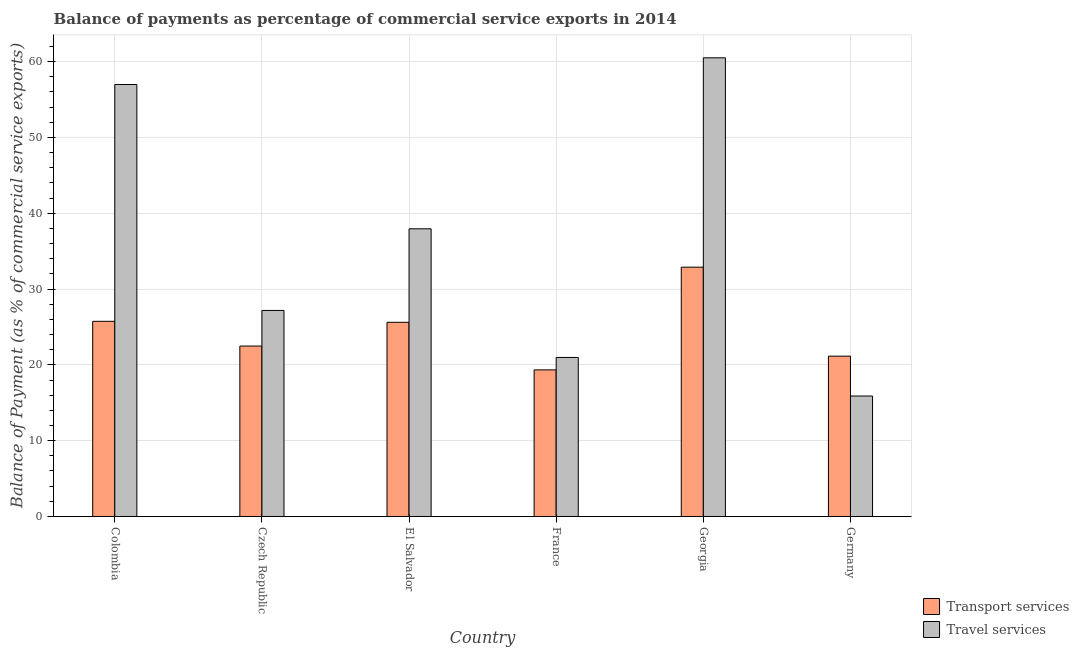How many groups of bars are there?
Keep it short and to the point. 6. Are the number of bars per tick equal to the number of legend labels?
Offer a terse response. Yes. Are the number of bars on each tick of the X-axis equal?
Your answer should be very brief. Yes. What is the label of the 3rd group of bars from the left?
Make the answer very short. El Salvador. In how many cases, is the number of bars for a given country not equal to the number of legend labels?
Your response must be concise. 0. What is the balance of payments of travel services in Colombia?
Ensure brevity in your answer.  56.98. Across all countries, what is the maximum balance of payments of transport services?
Ensure brevity in your answer.  32.89. Across all countries, what is the minimum balance of payments of travel services?
Your response must be concise. 15.89. In which country was the balance of payments of transport services maximum?
Keep it short and to the point. Georgia. In which country was the balance of payments of travel services minimum?
Your answer should be compact. Germany. What is the total balance of payments of transport services in the graph?
Provide a succinct answer. 147.21. What is the difference between the balance of payments of transport services in Georgia and that in Germany?
Keep it short and to the point. 11.74. What is the difference between the balance of payments of transport services in Germany and the balance of payments of travel services in France?
Your response must be concise. 0.17. What is the average balance of payments of travel services per country?
Your answer should be compact. 36.58. What is the difference between the balance of payments of transport services and balance of payments of travel services in Georgia?
Ensure brevity in your answer.  -27.61. In how many countries, is the balance of payments of travel services greater than 18 %?
Provide a short and direct response. 5. What is the ratio of the balance of payments of travel services in Czech Republic to that in France?
Keep it short and to the point. 1.3. Is the balance of payments of transport services in Colombia less than that in Georgia?
Offer a terse response. Yes. What is the difference between the highest and the second highest balance of payments of travel services?
Provide a succinct answer. 3.52. What is the difference between the highest and the lowest balance of payments of travel services?
Give a very brief answer. 44.61. What does the 1st bar from the left in Czech Republic represents?
Ensure brevity in your answer.  Transport services. What does the 1st bar from the right in Czech Republic represents?
Offer a terse response. Travel services. How many bars are there?
Make the answer very short. 12. Are all the bars in the graph horizontal?
Offer a terse response. No. How many countries are there in the graph?
Offer a very short reply. 6. What is the difference between two consecutive major ticks on the Y-axis?
Your answer should be compact. 10. Are the values on the major ticks of Y-axis written in scientific E-notation?
Provide a succinct answer. No. Does the graph contain any zero values?
Offer a terse response. No. Does the graph contain grids?
Ensure brevity in your answer.  Yes. Where does the legend appear in the graph?
Make the answer very short. Bottom right. How are the legend labels stacked?
Your answer should be very brief. Vertical. What is the title of the graph?
Offer a very short reply. Balance of payments as percentage of commercial service exports in 2014. Does "Current education expenditure" appear as one of the legend labels in the graph?
Your answer should be very brief. No. What is the label or title of the Y-axis?
Your response must be concise. Balance of Payment (as % of commercial service exports). What is the Balance of Payment (as % of commercial service exports) of Transport services in Colombia?
Your answer should be very brief. 25.74. What is the Balance of Payment (as % of commercial service exports) of Travel services in Colombia?
Offer a terse response. 56.98. What is the Balance of Payment (as % of commercial service exports) of Transport services in Czech Republic?
Ensure brevity in your answer.  22.48. What is the Balance of Payment (as % of commercial service exports) in Travel services in Czech Republic?
Give a very brief answer. 27.18. What is the Balance of Payment (as % of commercial service exports) of Transport services in El Salvador?
Make the answer very short. 25.61. What is the Balance of Payment (as % of commercial service exports) of Travel services in El Salvador?
Provide a short and direct response. 37.95. What is the Balance of Payment (as % of commercial service exports) in Transport services in France?
Keep it short and to the point. 19.34. What is the Balance of Payment (as % of commercial service exports) in Travel services in France?
Provide a succinct answer. 20.98. What is the Balance of Payment (as % of commercial service exports) in Transport services in Georgia?
Provide a short and direct response. 32.89. What is the Balance of Payment (as % of commercial service exports) of Travel services in Georgia?
Provide a short and direct response. 60.5. What is the Balance of Payment (as % of commercial service exports) of Transport services in Germany?
Your response must be concise. 21.15. What is the Balance of Payment (as % of commercial service exports) in Travel services in Germany?
Keep it short and to the point. 15.89. Across all countries, what is the maximum Balance of Payment (as % of commercial service exports) of Transport services?
Offer a very short reply. 32.89. Across all countries, what is the maximum Balance of Payment (as % of commercial service exports) in Travel services?
Provide a succinct answer. 60.5. Across all countries, what is the minimum Balance of Payment (as % of commercial service exports) in Transport services?
Make the answer very short. 19.34. Across all countries, what is the minimum Balance of Payment (as % of commercial service exports) in Travel services?
Your answer should be very brief. 15.89. What is the total Balance of Payment (as % of commercial service exports) in Transport services in the graph?
Your response must be concise. 147.21. What is the total Balance of Payment (as % of commercial service exports) in Travel services in the graph?
Your response must be concise. 219.47. What is the difference between the Balance of Payment (as % of commercial service exports) of Transport services in Colombia and that in Czech Republic?
Offer a terse response. 3.26. What is the difference between the Balance of Payment (as % of commercial service exports) in Travel services in Colombia and that in Czech Republic?
Your answer should be compact. 29.8. What is the difference between the Balance of Payment (as % of commercial service exports) in Transport services in Colombia and that in El Salvador?
Ensure brevity in your answer.  0.13. What is the difference between the Balance of Payment (as % of commercial service exports) in Travel services in Colombia and that in El Salvador?
Offer a terse response. 19.03. What is the difference between the Balance of Payment (as % of commercial service exports) in Transport services in Colombia and that in France?
Give a very brief answer. 6.41. What is the difference between the Balance of Payment (as % of commercial service exports) of Travel services in Colombia and that in France?
Offer a terse response. 36.01. What is the difference between the Balance of Payment (as % of commercial service exports) in Transport services in Colombia and that in Georgia?
Offer a terse response. -7.14. What is the difference between the Balance of Payment (as % of commercial service exports) of Travel services in Colombia and that in Georgia?
Your response must be concise. -3.52. What is the difference between the Balance of Payment (as % of commercial service exports) in Transport services in Colombia and that in Germany?
Your response must be concise. 4.6. What is the difference between the Balance of Payment (as % of commercial service exports) of Travel services in Colombia and that in Germany?
Make the answer very short. 41.09. What is the difference between the Balance of Payment (as % of commercial service exports) of Transport services in Czech Republic and that in El Salvador?
Make the answer very short. -3.13. What is the difference between the Balance of Payment (as % of commercial service exports) in Travel services in Czech Republic and that in El Salvador?
Make the answer very short. -10.77. What is the difference between the Balance of Payment (as % of commercial service exports) of Transport services in Czech Republic and that in France?
Your answer should be compact. 3.14. What is the difference between the Balance of Payment (as % of commercial service exports) in Travel services in Czech Republic and that in France?
Provide a short and direct response. 6.2. What is the difference between the Balance of Payment (as % of commercial service exports) of Transport services in Czech Republic and that in Georgia?
Make the answer very short. -10.41. What is the difference between the Balance of Payment (as % of commercial service exports) in Travel services in Czech Republic and that in Georgia?
Your answer should be compact. -33.32. What is the difference between the Balance of Payment (as % of commercial service exports) in Transport services in Czech Republic and that in Germany?
Offer a terse response. 1.33. What is the difference between the Balance of Payment (as % of commercial service exports) in Travel services in Czech Republic and that in Germany?
Provide a succinct answer. 11.29. What is the difference between the Balance of Payment (as % of commercial service exports) in Transport services in El Salvador and that in France?
Give a very brief answer. 6.28. What is the difference between the Balance of Payment (as % of commercial service exports) in Travel services in El Salvador and that in France?
Provide a short and direct response. 16.97. What is the difference between the Balance of Payment (as % of commercial service exports) of Transport services in El Salvador and that in Georgia?
Your answer should be compact. -7.27. What is the difference between the Balance of Payment (as % of commercial service exports) of Travel services in El Salvador and that in Georgia?
Provide a succinct answer. -22.56. What is the difference between the Balance of Payment (as % of commercial service exports) of Transport services in El Salvador and that in Germany?
Your answer should be compact. 4.47. What is the difference between the Balance of Payment (as % of commercial service exports) in Travel services in El Salvador and that in Germany?
Offer a terse response. 22.06. What is the difference between the Balance of Payment (as % of commercial service exports) of Transport services in France and that in Georgia?
Offer a very short reply. -13.55. What is the difference between the Balance of Payment (as % of commercial service exports) in Travel services in France and that in Georgia?
Your answer should be very brief. -39.53. What is the difference between the Balance of Payment (as % of commercial service exports) in Transport services in France and that in Germany?
Offer a very short reply. -1.81. What is the difference between the Balance of Payment (as % of commercial service exports) in Travel services in France and that in Germany?
Provide a succinct answer. 5.09. What is the difference between the Balance of Payment (as % of commercial service exports) of Transport services in Georgia and that in Germany?
Provide a short and direct response. 11.74. What is the difference between the Balance of Payment (as % of commercial service exports) of Travel services in Georgia and that in Germany?
Your response must be concise. 44.61. What is the difference between the Balance of Payment (as % of commercial service exports) of Transport services in Colombia and the Balance of Payment (as % of commercial service exports) of Travel services in Czech Republic?
Keep it short and to the point. -1.43. What is the difference between the Balance of Payment (as % of commercial service exports) of Transport services in Colombia and the Balance of Payment (as % of commercial service exports) of Travel services in El Salvador?
Offer a very short reply. -12.2. What is the difference between the Balance of Payment (as % of commercial service exports) in Transport services in Colombia and the Balance of Payment (as % of commercial service exports) in Travel services in France?
Ensure brevity in your answer.  4.77. What is the difference between the Balance of Payment (as % of commercial service exports) in Transport services in Colombia and the Balance of Payment (as % of commercial service exports) in Travel services in Georgia?
Keep it short and to the point. -34.76. What is the difference between the Balance of Payment (as % of commercial service exports) of Transport services in Colombia and the Balance of Payment (as % of commercial service exports) of Travel services in Germany?
Your response must be concise. 9.85. What is the difference between the Balance of Payment (as % of commercial service exports) in Transport services in Czech Republic and the Balance of Payment (as % of commercial service exports) in Travel services in El Salvador?
Keep it short and to the point. -15.47. What is the difference between the Balance of Payment (as % of commercial service exports) in Transport services in Czech Republic and the Balance of Payment (as % of commercial service exports) in Travel services in France?
Ensure brevity in your answer.  1.5. What is the difference between the Balance of Payment (as % of commercial service exports) in Transport services in Czech Republic and the Balance of Payment (as % of commercial service exports) in Travel services in Georgia?
Provide a short and direct response. -38.02. What is the difference between the Balance of Payment (as % of commercial service exports) in Transport services in Czech Republic and the Balance of Payment (as % of commercial service exports) in Travel services in Germany?
Your answer should be very brief. 6.59. What is the difference between the Balance of Payment (as % of commercial service exports) of Transport services in El Salvador and the Balance of Payment (as % of commercial service exports) of Travel services in France?
Your response must be concise. 4.64. What is the difference between the Balance of Payment (as % of commercial service exports) in Transport services in El Salvador and the Balance of Payment (as % of commercial service exports) in Travel services in Georgia?
Keep it short and to the point. -34.89. What is the difference between the Balance of Payment (as % of commercial service exports) in Transport services in El Salvador and the Balance of Payment (as % of commercial service exports) in Travel services in Germany?
Provide a short and direct response. 9.73. What is the difference between the Balance of Payment (as % of commercial service exports) in Transport services in France and the Balance of Payment (as % of commercial service exports) in Travel services in Georgia?
Your answer should be compact. -41.17. What is the difference between the Balance of Payment (as % of commercial service exports) in Transport services in France and the Balance of Payment (as % of commercial service exports) in Travel services in Germany?
Provide a short and direct response. 3.45. What is the difference between the Balance of Payment (as % of commercial service exports) of Transport services in Georgia and the Balance of Payment (as % of commercial service exports) of Travel services in Germany?
Keep it short and to the point. 17. What is the average Balance of Payment (as % of commercial service exports) of Transport services per country?
Provide a short and direct response. 24.54. What is the average Balance of Payment (as % of commercial service exports) in Travel services per country?
Your response must be concise. 36.58. What is the difference between the Balance of Payment (as % of commercial service exports) in Transport services and Balance of Payment (as % of commercial service exports) in Travel services in Colombia?
Your answer should be very brief. -31.24. What is the difference between the Balance of Payment (as % of commercial service exports) in Transport services and Balance of Payment (as % of commercial service exports) in Travel services in Czech Republic?
Make the answer very short. -4.7. What is the difference between the Balance of Payment (as % of commercial service exports) of Transport services and Balance of Payment (as % of commercial service exports) of Travel services in El Salvador?
Provide a succinct answer. -12.33. What is the difference between the Balance of Payment (as % of commercial service exports) in Transport services and Balance of Payment (as % of commercial service exports) in Travel services in France?
Keep it short and to the point. -1.64. What is the difference between the Balance of Payment (as % of commercial service exports) of Transport services and Balance of Payment (as % of commercial service exports) of Travel services in Georgia?
Ensure brevity in your answer.  -27.61. What is the difference between the Balance of Payment (as % of commercial service exports) in Transport services and Balance of Payment (as % of commercial service exports) in Travel services in Germany?
Make the answer very short. 5.26. What is the ratio of the Balance of Payment (as % of commercial service exports) of Transport services in Colombia to that in Czech Republic?
Give a very brief answer. 1.15. What is the ratio of the Balance of Payment (as % of commercial service exports) in Travel services in Colombia to that in Czech Republic?
Provide a succinct answer. 2.1. What is the ratio of the Balance of Payment (as % of commercial service exports) of Transport services in Colombia to that in El Salvador?
Provide a short and direct response. 1.01. What is the ratio of the Balance of Payment (as % of commercial service exports) of Travel services in Colombia to that in El Salvador?
Your answer should be compact. 1.5. What is the ratio of the Balance of Payment (as % of commercial service exports) of Transport services in Colombia to that in France?
Keep it short and to the point. 1.33. What is the ratio of the Balance of Payment (as % of commercial service exports) in Travel services in Colombia to that in France?
Make the answer very short. 2.72. What is the ratio of the Balance of Payment (as % of commercial service exports) of Transport services in Colombia to that in Georgia?
Make the answer very short. 0.78. What is the ratio of the Balance of Payment (as % of commercial service exports) in Travel services in Colombia to that in Georgia?
Your answer should be compact. 0.94. What is the ratio of the Balance of Payment (as % of commercial service exports) of Transport services in Colombia to that in Germany?
Keep it short and to the point. 1.22. What is the ratio of the Balance of Payment (as % of commercial service exports) of Travel services in Colombia to that in Germany?
Offer a very short reply. 3.59. What is the ratio of the Balance of Payment (as % of commercial service exports) of Transport services in Czech Republic to that in El Salvador?
Your response must be concise. 0.88. What is the ratio of the Balance of Payment (as % of commercial service exports) of Travel services in Czech Republic to that in El Salvador?
Your response must be concise. 0.72. What is the ratio of the Balance of Payment (as % of commercial service exports) of Transport services in Czech Republic to that in France?
Give a very brief answer. 1.16. What is the ratio of the Balance of Payment (as % of commercial service exports) in Travel services in Czech Republic to that in France?
Provide a succinct answer. 1.3. What is the ratio of the Balance of Payment (as % of commercial service exports) of Transport services in Czech Republic to that in Georgia?
Make the answer very short. 0.68. What is the ratio of the Balance of Payment (as % of commercial service exports) of Travel services in Czech Republic to that in Georgia?
Offer a terse response. 0.45. What is the ratio of the Balance of Payment (as % of commercial service exports) in Transport services in Czech Republic to that in Germany?
Make the answer very short. 1.06. What is the ratio of the Balance of Payment (as % of commercial service exports) in Travel services in Czech Republic to that in Germany?
Provide a succinct answer. 1.71. What is the ratio of the Balance of Payment (as % of commercial service exports) of Transport services in El Salvador to that in France?
Your answer should be compact. 1.32. What is the ratio of the Balance of Payment (as % of commercial service exports) in Travel services in El Salvador to that in France?
Give a very brief answer. 1.81. What is the ratio of the Balance of Payment (as % of commercial service exports) in Transport services in El Salvador to that in Georgia?
Provide a short and direct response. 0.78. What is the ratio of the Balance of Payment (as % of commercial service exports) of Travel services in El Salvador to that in Georgia?
Your response must be concise. 0.63. What is the ratio of the Balance of Payment (as % of commercial service exports) of Transport services in El Salvador to that in Germany?
Provide a short and direct response. 1.21. What is the ratio of the Balance of Payment (as % of commercial service exports) of Travel services in El Salvador to that in Germany?
Provide a short and direct response. 2.39. What is the ratio of the Balance of Payment (as % of commercial service exports) of Transport services in France to that in Georgia?
Provide a succinct answer. 0.59. What is the ratio of the Balance of Payment (as % of commercial service exports) in Travel services in France to that in Georgia?
Your answer should be very brief. 0.35. What is the ratio of the Balance of Payment (as % of commercial service exports) in Transport services in France to that in Germany?
Provide a succinct answer. 0.91. What is the ratio of the Balance of Payment (as % of commercial service exports) in Travel services in France to that in Germany?
Keep it short and to the point. 1.32. What is the ratio of the Balance of Payment (as % of commercial service exports) of Transport services in Georgia to that in Germany?
Your response must be concise. 1.56. What is the ratio of the Balance of Payment (as % of commercial service exports) in Travel services in Georgia to that in Germany?
Provide a succinct answer. 3.81. What is the difference between the highest and the second highest Balance of Payment (as % of commercial service exports) in Transport services?
Give a very brief answer. 7.14. What is the difference between the highest and the second highest Balance of Payment (as % of commercial service exports) of Travel services?
Offer a terse response. 3.52. What is the difference between the highest and the lowest Balance of Payment (as % of commercial service exports) of Transport services?
Offer a very short reply. 13.55. What is the difference between the highest and the lowest Balance of Payment (as % of commercial service exports) in Travel services?
Make the answer very short. 44.61. 